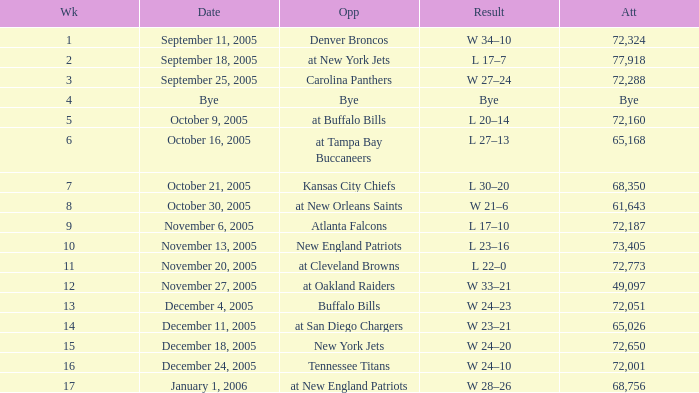What is the Date of the game with an attendance of 72,051 after Week 9? December 4, 2005. 